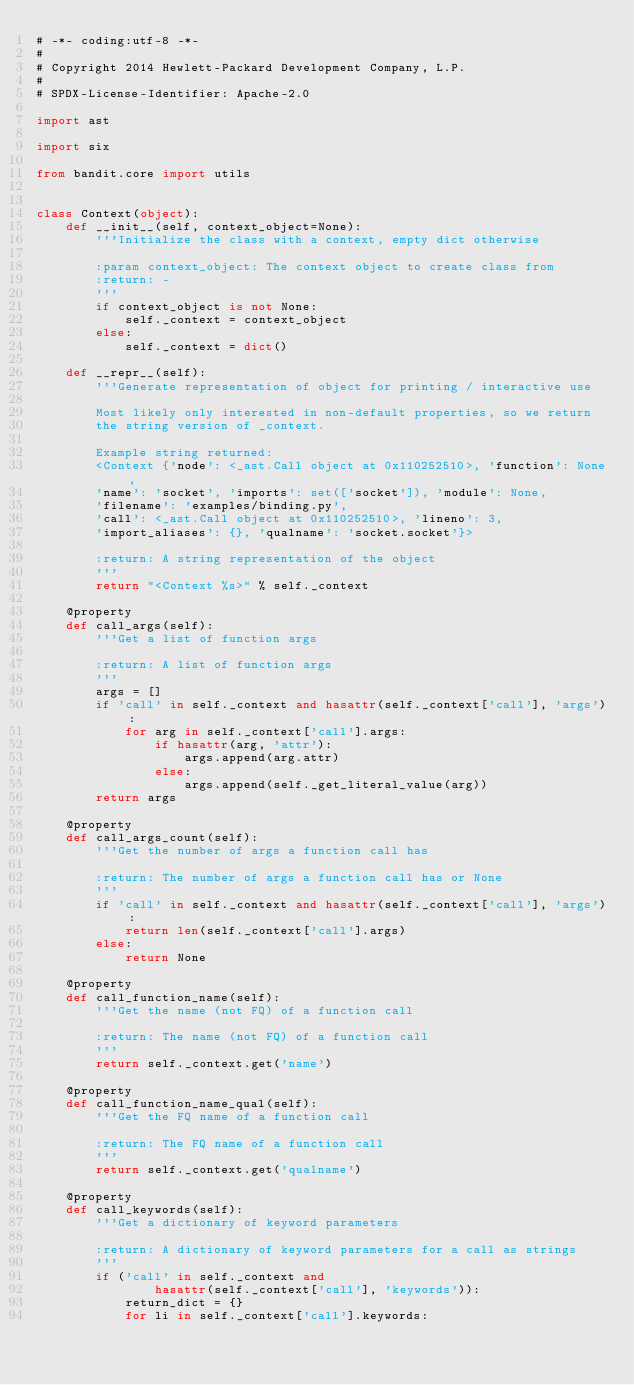<code> <loc_0><loc_0><loc_500><loc_500><_Python_># -*- coding:utf-8 -*-
#
# Copyright 2014 Hewlett-Packard Development Company, L.P.
#
# SPDX-License-Identifier: Apache-2.0

import ast

import six

from bandit.core import utils


class Context(object):
    def __init__(self, context_object=None):
        '''Initialize the class with a context, empty dict otherwise

        :param context_object: The context object to create class from
        :return: -
        '''
        if context_object is not None:
            self._context = context_object
        else:
            self._context = dict()

    def __repr__(self):
        '''Generate representation of object for printing / interactive use

        Most likely only interested in non-default properties, so we return
        the string version of _context.

        Example string returned:
        <Context {'node': <_ast.Call object at 0x110252510>, 'function': None,
        'name': 'socket', 'imports': set(['socket']), 'module': None,
        'filename': 'examples/binding.py',
        'call': <_ast.Call object at 0x110252510>, 'lineno': 3,
        'import_aliases': {}, 'qualname': 'socket.socket'}>

        :return: A string representation of the object
        '''
        return "<Context %s>" % self._context

    @property
    def call_args(self):
        '''Get a list of function args

        :return: A list of function args
        '''
        args = []
        if 'call' in self._context and hasattr(self._context['call'], 'args'):
            for arg in self._context['call'].args:
                if hasattr(arg, 'attr'):
                    args.append(arg.attr)
                else:
                    args.append(self._get_literal_value(arg))
        return args

    @property
    def call_args_count(self):
        '''Get the number of args a function call has

        :return: The number of args a function call has or None
        '''
        if 'call' in self._context and hasattr(self._context['call'], 'args'):
            return len(self._context['call'].args)
        else:
            return None

    @property
    def call_function_name(self):
        '''Get the name (not FQ) of a function call

        :return: The name (not FQ) of a function call
        '''
        return self._context.get('name')

    @property
    def call_function_name_qual(self):
        '''Get the FQ name of a function call

        :return: The FQ name of a function call
        '''
        return self._context.get('qualname')

    @property
    def call_keywords(self):
        '''Get a dictionary of keyword parameters

        :return: A dictionary of keyword parameters for a call as strings
        '''
        if ('call' in self._context and
                hasattr(self._context['call'], 'keywords')):
            return_dict = {}
            for li in self._context['call'].keywords:</code> 